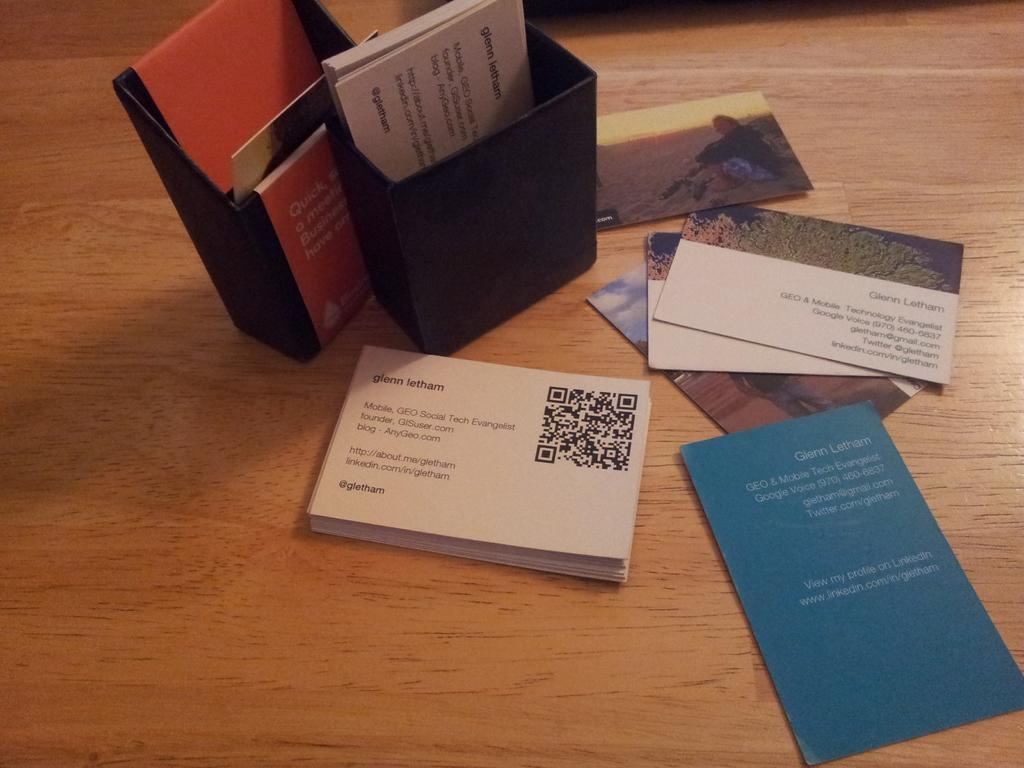What type of surface is visible in the image? There is a wooden surface in the image. What is placed on the wooden surface? There are papers and photos on the wooden surface. How many boxes are on the wooden surface? There are two boxes on the wooden surface. What month is depicted in the photos on the wooden surface? The provided facts do not mention any specific month or time frame depicted in the photos, so it cannot be determined from the image. 